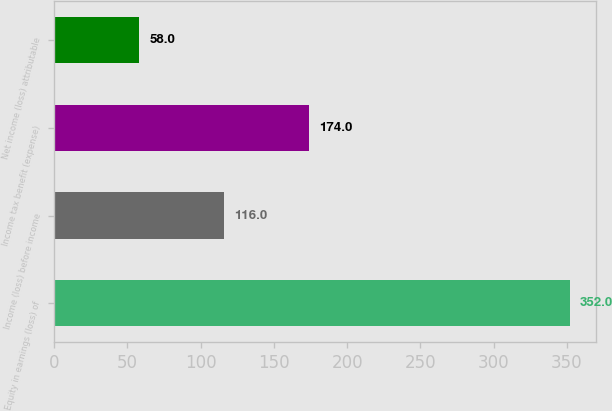Convert chart to OTSL. <chart><loc_0><loc_0><loc_500><loc_500><bar_chart><fcel>Equity in earnings (loss) of<fcel>Income (loss) before income<fcel>Income tax benefit (expense)<fcel>Net income (loss) attributable<nl><fcel>352<fcel>116<fcel>174<fcel>58<nl></chart> 